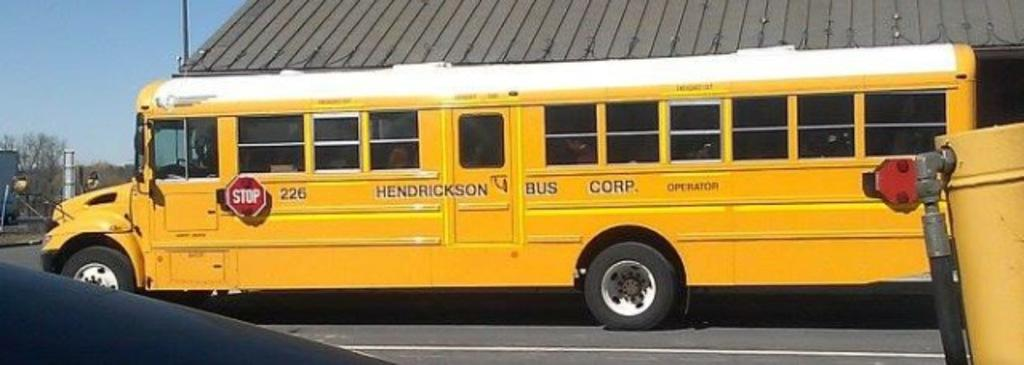<image>
Share a concise interpretation of the image provided. A yellow school bus from Henderson Bus Corp. 